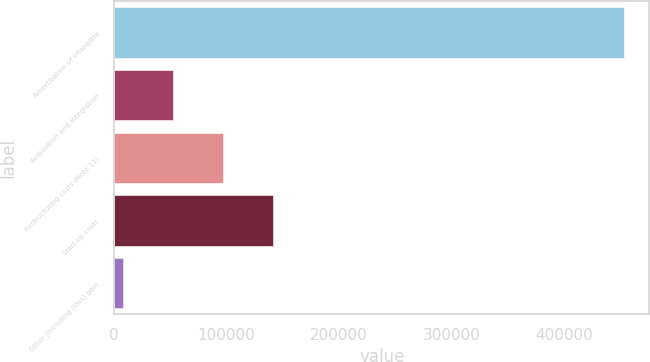Convert chart. <chart><loc_0><loc_0><loc_500><loc_500><bar_chart><fcel>Amortization of intangible<fcel>Acquisition and integration<fcel>Restructuring costs (Note 11)<fcel>Start-up costs<fcel>Other (including (loss) gain<nl><fcel>453515<fcel>52068.2<fcel>96673.4<fcel>141279<fcel>7463<nl></chart> 